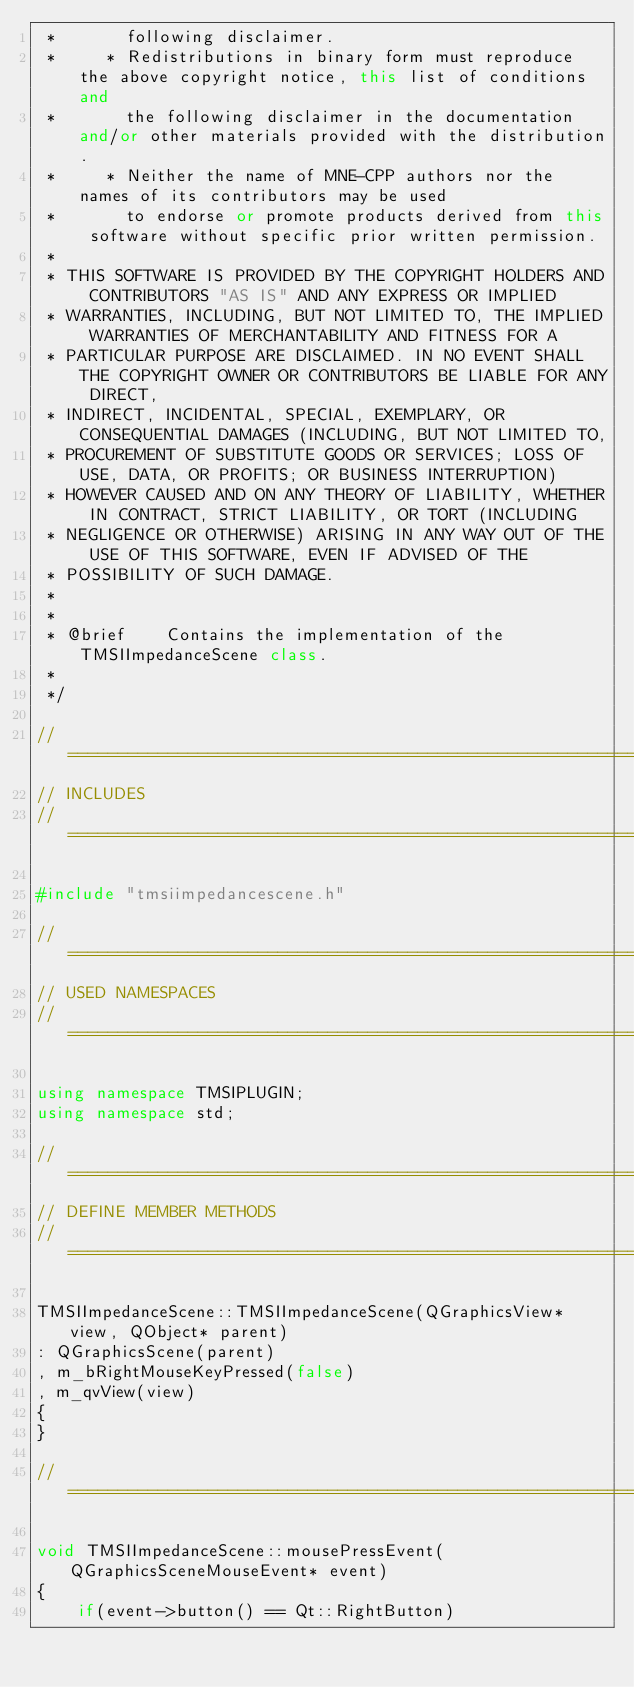Convert code to text. <code><loc_0><loc_0><loc_500><loc_500><_C++_> *       following disclaimer.
 *     * Redistributions in binary form must reproduce the above copyright notice, this list of conditions and
 *       the following disclaimer in the documentation and/or other materials provided with the distribution.
 *     * Neither the name of MNE-CPP authors nor the names of its contributors may be used
 *       to endorse or promote products derived from this software without specific prior written permission.
 *
 * THIS SOFTWARE IS PROVIDED BY THE COPYRIGHT HOLDERS AND CONTRIBUTORS "AS IS" AND ANY EXPRESS OR IMPLIED
 * WARRANTIES, INCLUDING, BUT NOT LIMITED TO, THE IMPLIED WARRANTIES OF MERCHANTABILITY AND FITNESS FOR A
 * PARTICULAR PURPOSE ARE DISCLAIMED. IN NO EVENT SHALL THE COPYRIGHT OWNER OR CONTRIBUTORS BE LIABLE FOR ANY DIRECT,
 * INDIRECT, INCIDENTAL, SPECIAL, EXEMPLARY, OR CONSEQUENTIAL DAMAGES (INCLUDING, BUT NOT LIMITED TO,
 * PROCUREMENT OF SUBSTITUTE GOODS OR SERVICES; LOSS OF USE, DATA, OR PROFITS; OR BUSINESS INTERRUPTION)
 * HOWEVER CAUSED AND ON ANY THEORY OF LIABILITY, WHETHER IN CONTRACT, STRICT LIABILITY, OR TORT (INCLUDING
 * NEGLIGENCE OR OTHERWISE) ARISING IN ANY WAY OUT OF THE USE OF THIS SOFTWARE, EVEN IF ADVISED OF THE
 * POSSIBILITY OF SUCH DAMAGE.
 *
 *
 * @brief    Contains the implementation of the TMSIImpedanceScene class.
 *
 */

//=============================================================================================================
// INCLUDES
//=============================================================================================================

#include "tmsiimpedancescene.h"

//=============================================================================================================
// USED NAMESPACES
//=============================================================================================================

using namespace TMSIPLUGIN;
using namespace std;

//=============================================================================================================
// DEFINE MEMBER METHODS
//=============================================================================================================

TMSIImpedanceScene::TMSIImpedanceScene(QGraphicsView* view, QObject* parent)
: QGraphicsScene(parent)
, m_bRightMouseKeyPressed(false)
, m_qvView(view)
{
}

//=============================================================================================================

void TMSIImpedanceScene::mousePressEvent(QGraphicsSceneMouseEvent* event)
{
    if(event->button() == Qt::RightButton)</code> 